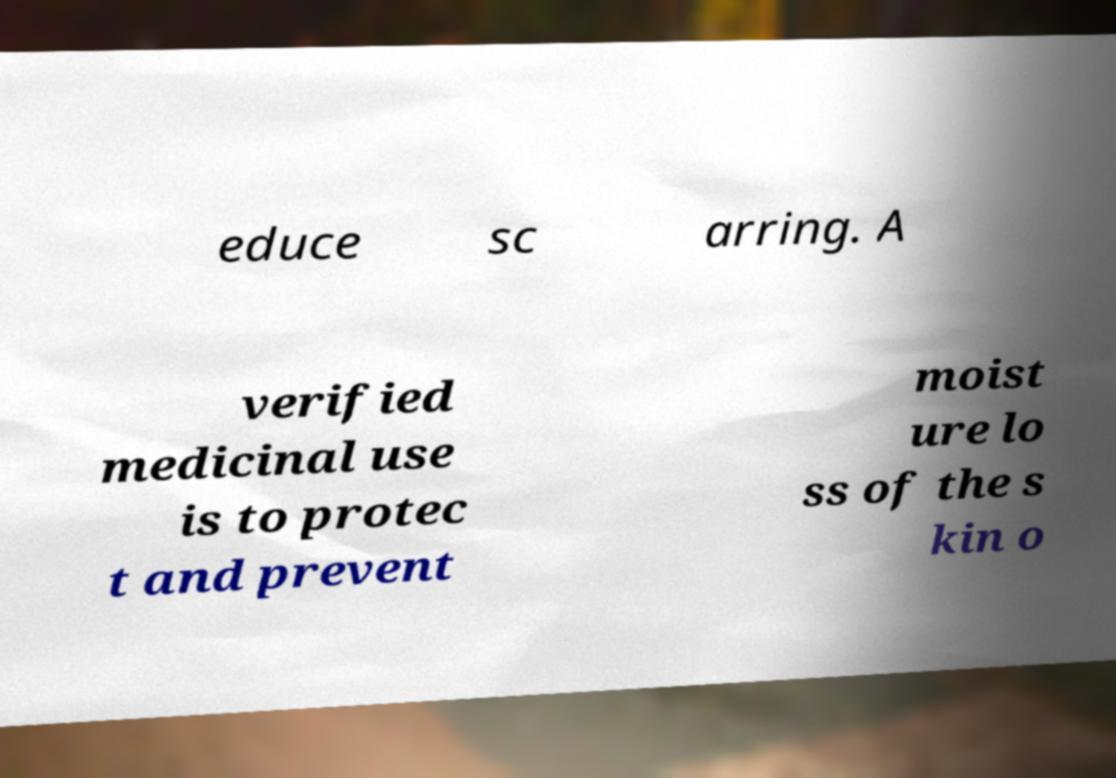There's text embedded in this image that I need extracted. Can you transcribe it verbatim? educe sc arring. A verified medicinal use is to protec t and prevent moist ure lo ss of the s kin o 